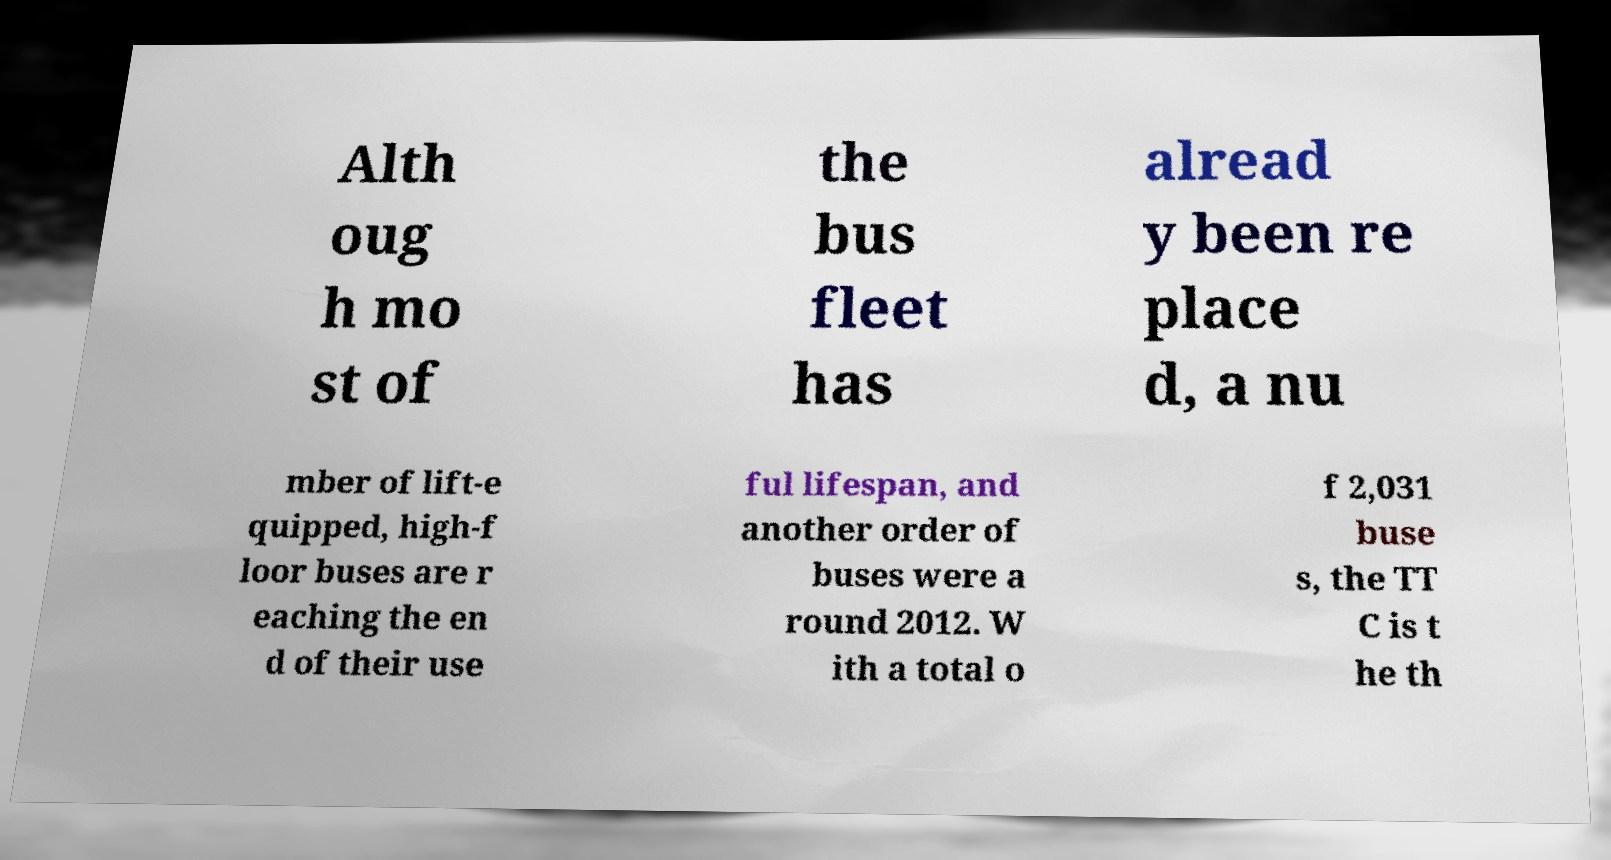Could you extract and type out the text from this image? Alth oug h mo st of the bus fleet has alread y been re place d, a nu mber of lift-e quipped, high-f loor buses are r eaching the en d of their use ful lifespan, and another order of buses were a round 2012. W ith a total o f 2,031 buse s, the TT C is t he th 